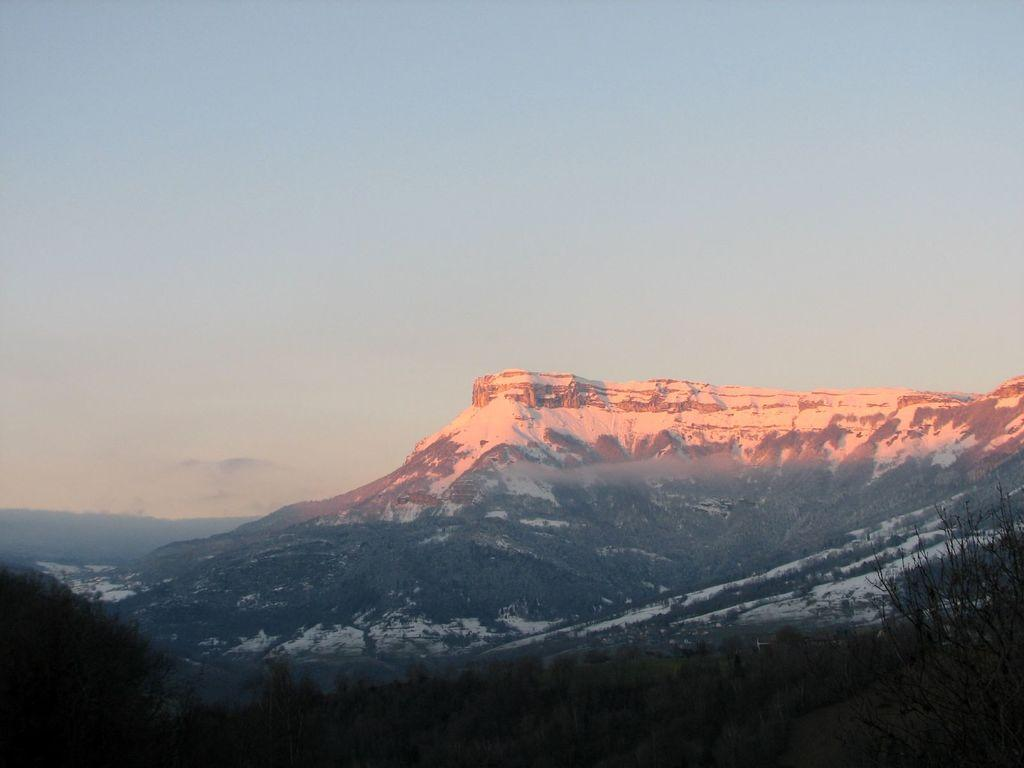What type of terrain is visible in the image? There are hills with snow in the image. What type of vegetation can be seen in the image? There are trees and plants in the image. What part of the natural environment is visible in the image? The sky is visible in the image. What type of notebook is being used by the toad in the image? There is no toad or notebook present in the image. Can you describe the kiss between the plants in the image? There are no kisses or interactions between plants depicted in the image. 